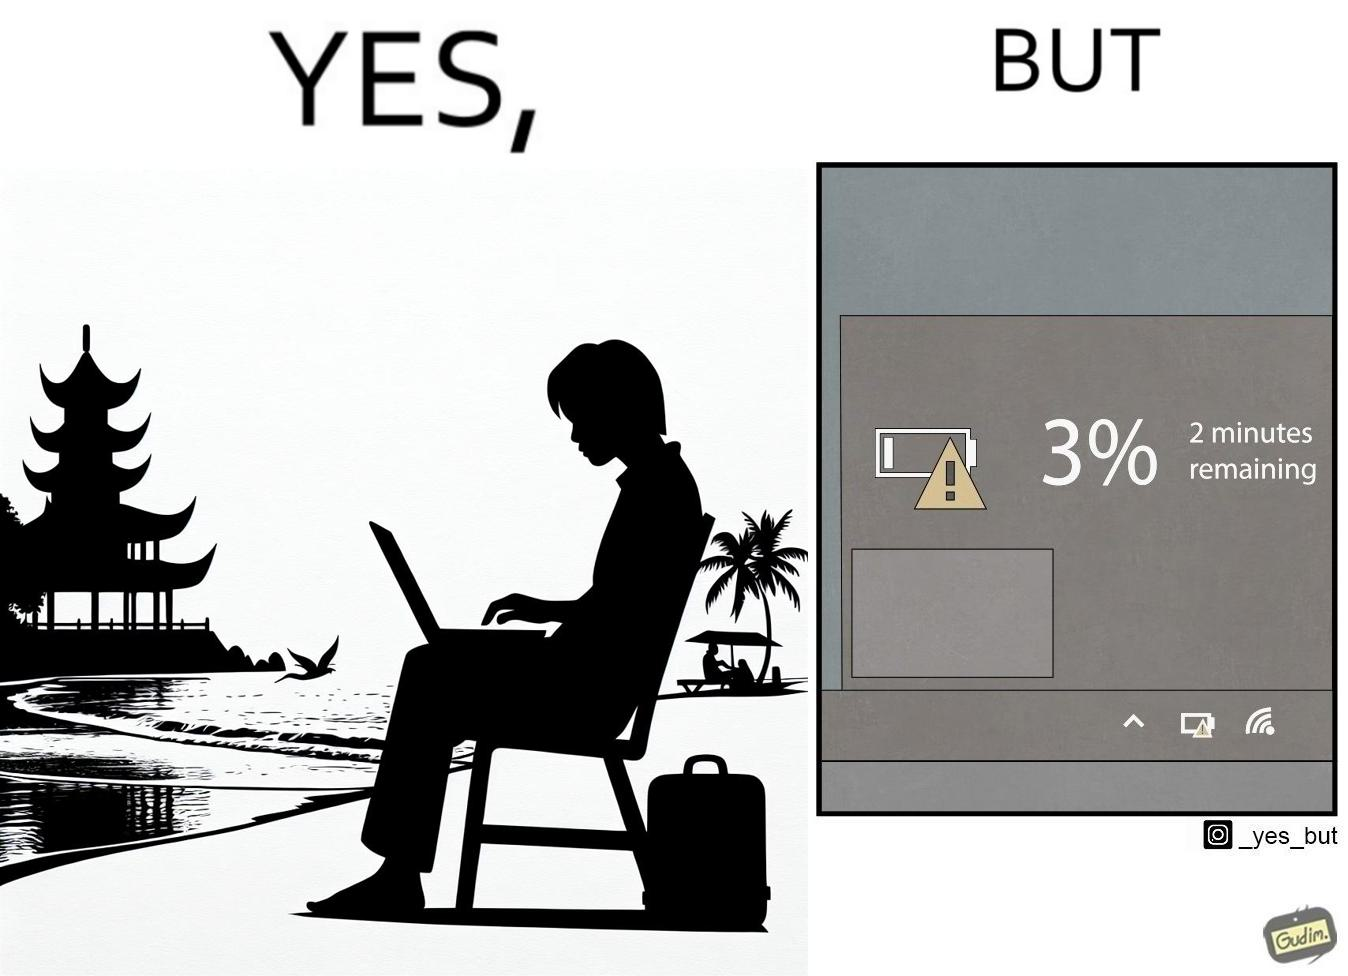What is the satirical meaning behind this image? The image is ironical, as a person is working on a laptop in a beach, which looks like a soothing and calm environment to work. However, the laptop is about to get discharged, and there is probably no electric supply to keep the laptop open while working on the beach, turning the situation into an inconvenience. 